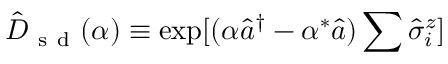Convert formula to latex. <formula><loc_0><loc_0><loc_500><loc_500>\hat { D } _ { s d } ( \alpha ) \equiv \exp [ ( \alpha \hat { a } ^ { \dagger } - \alpha ^ { \ast } \hat { a } ) \sum \hat { \sigma } _ { i } ^ { z } ]</formula> 